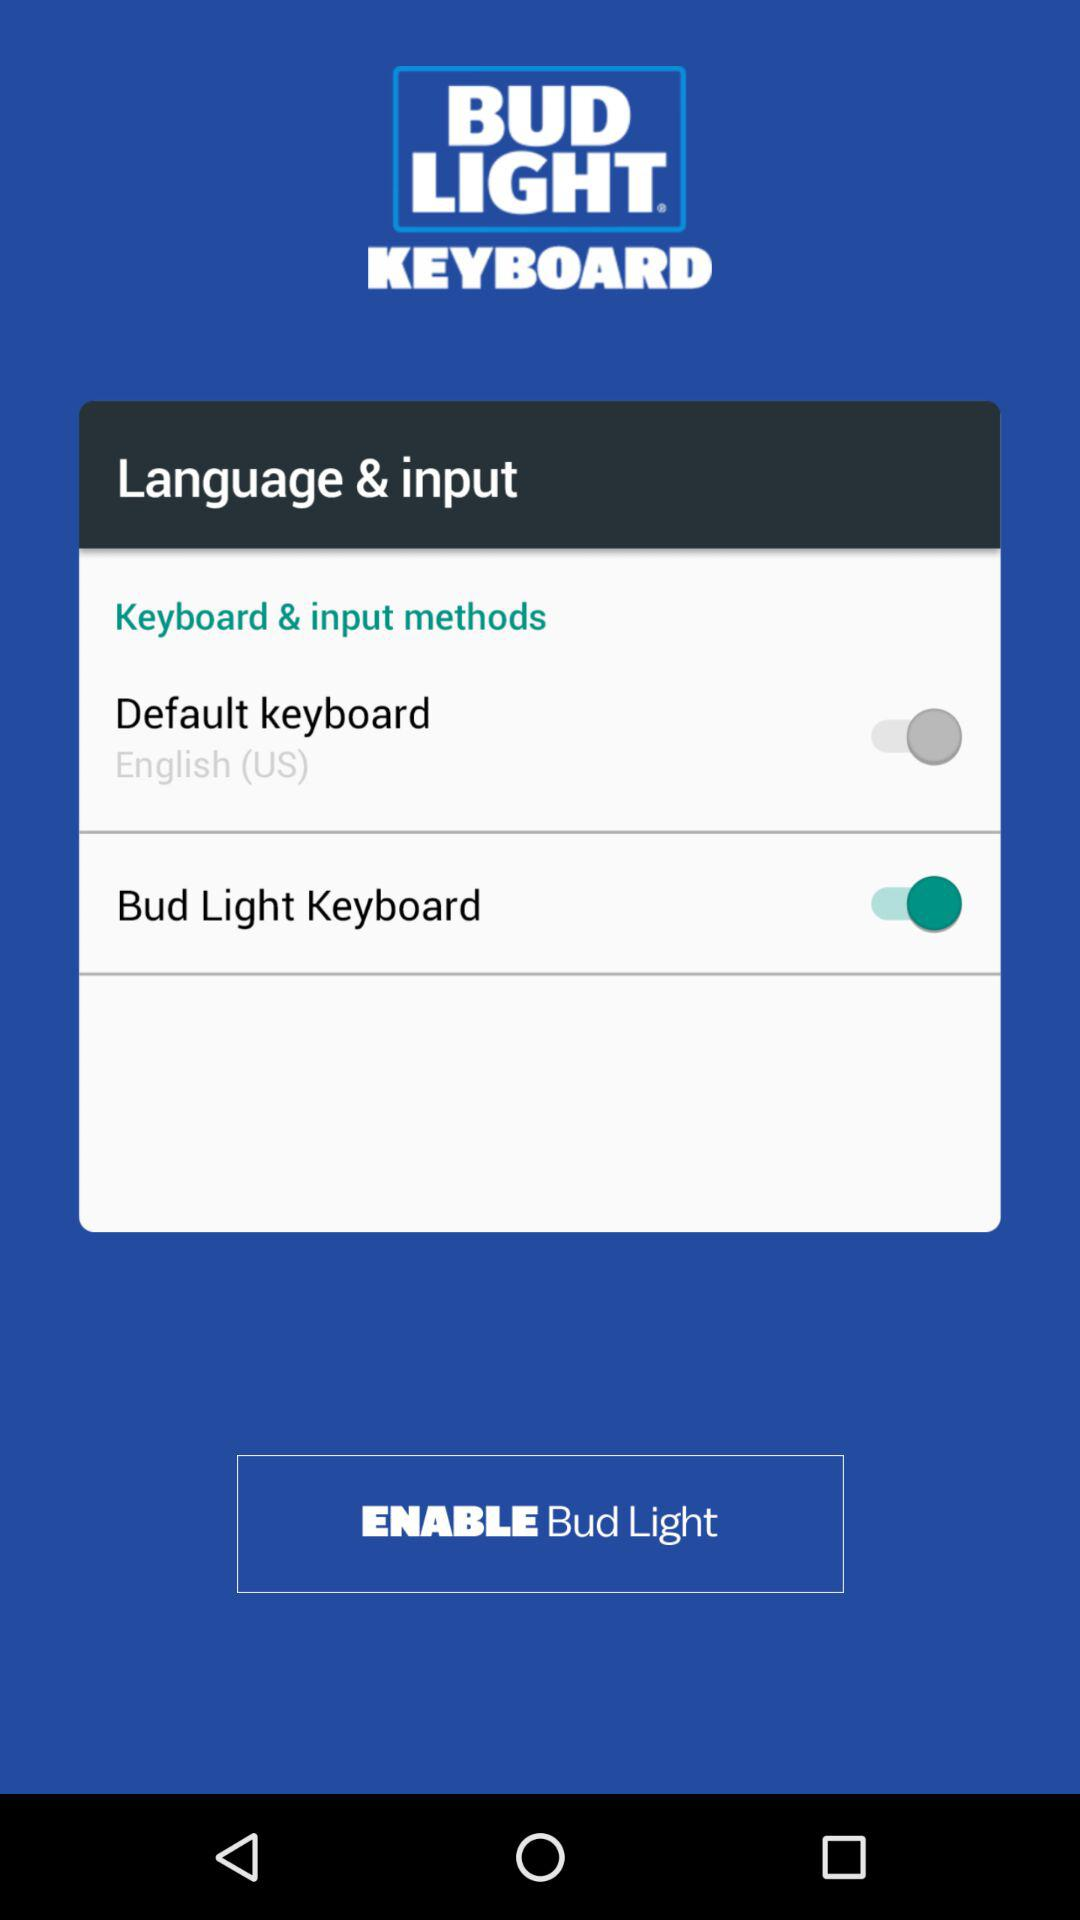How many input methods are available?
Answer the question using a single word or phrase. 2 